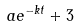Convert formula to latex. <formula><loc_0><loc_0><loc_500><loc_500>a e ^ { - k t } + 3</formula> 